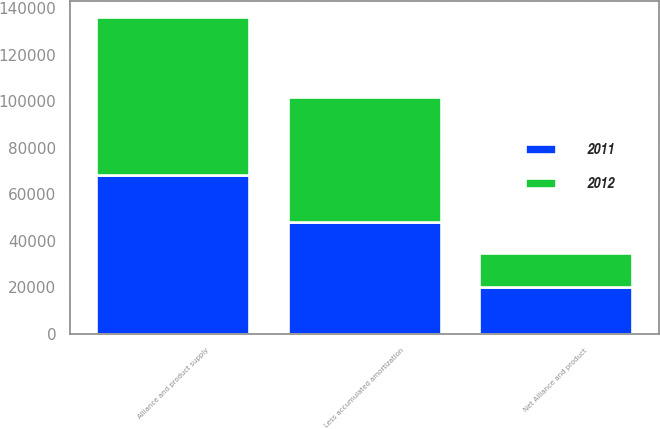<chart> <loc_0><loc_0><loc_500><loc_500><stacked_bar_chart><ecel><fcel>Alliance and product supply<fcel>Less accumulated amortization<fcel>Net Alliance and product<nl><fcel>2012<fcel>68200<fcel>53543<fcel>14657<nl><fcel>2011<fcel>68200<fcel>48213<fcel>19987<nl></chart> 